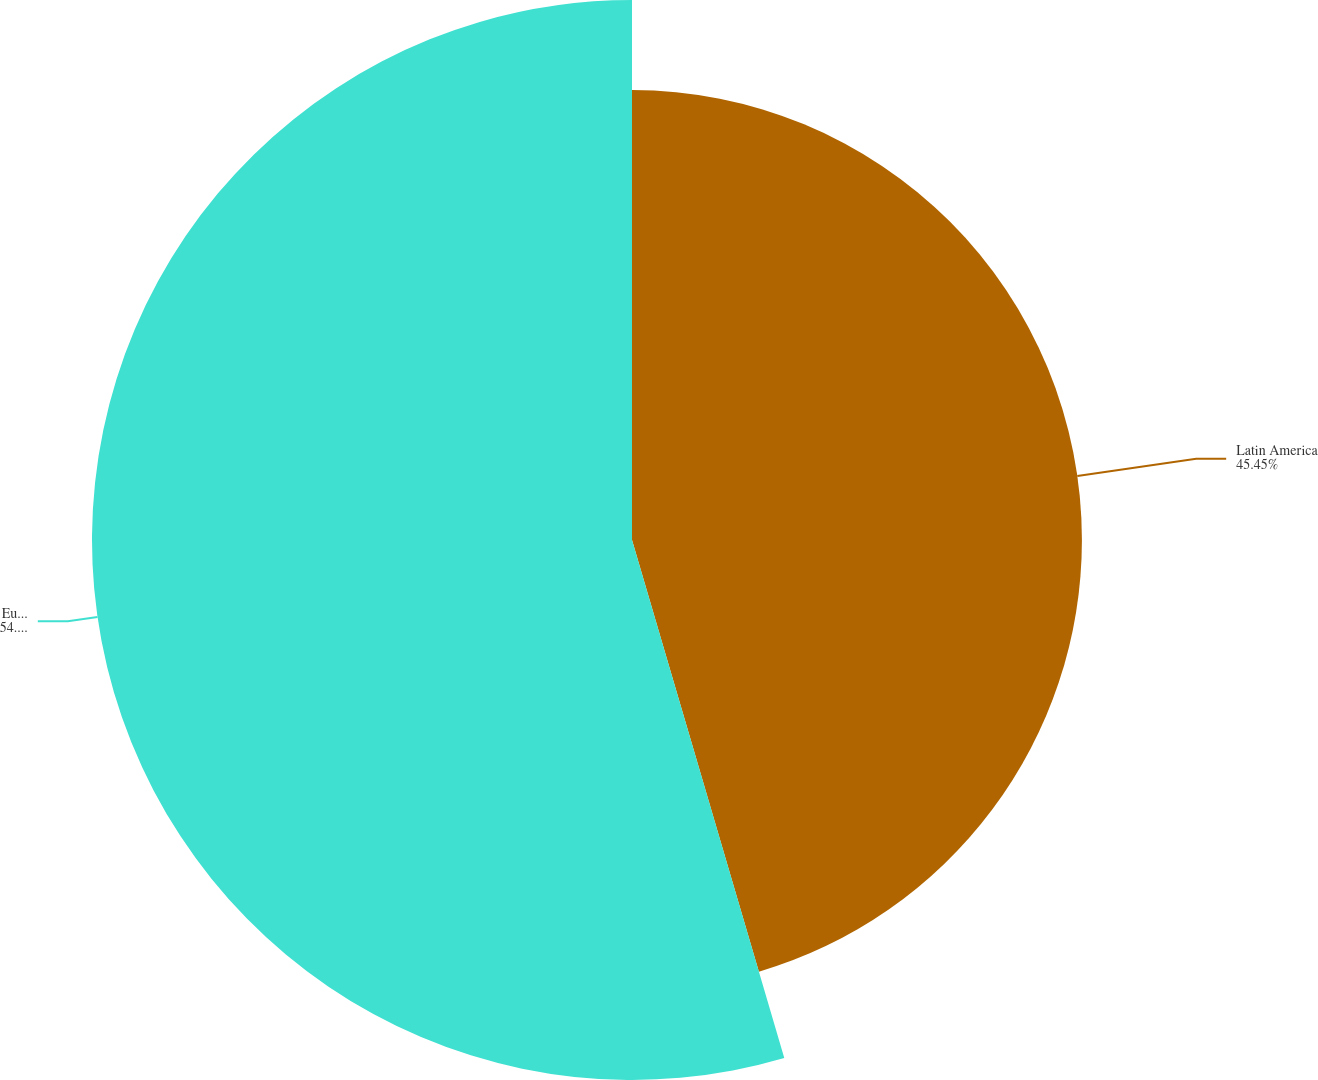Convert chart. <chart><loc_0><loc_0><loc_500><loc_500><pie_chart><fcel>Latin America<fcel>Europe/South Pacific<nl><fcel>45.45%<fcel>54.55%<nl></chart> 